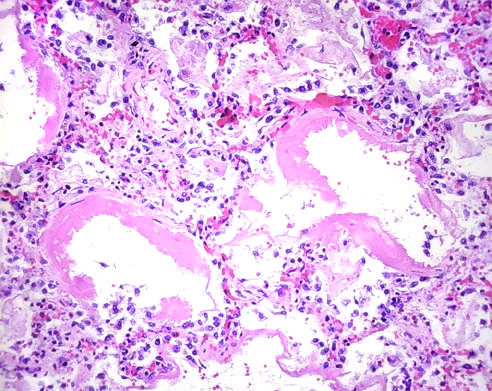re the principal cellular alterations that characterize reversible cell injury and necrosis distended?
Answer the question using a single word or phrase. No 